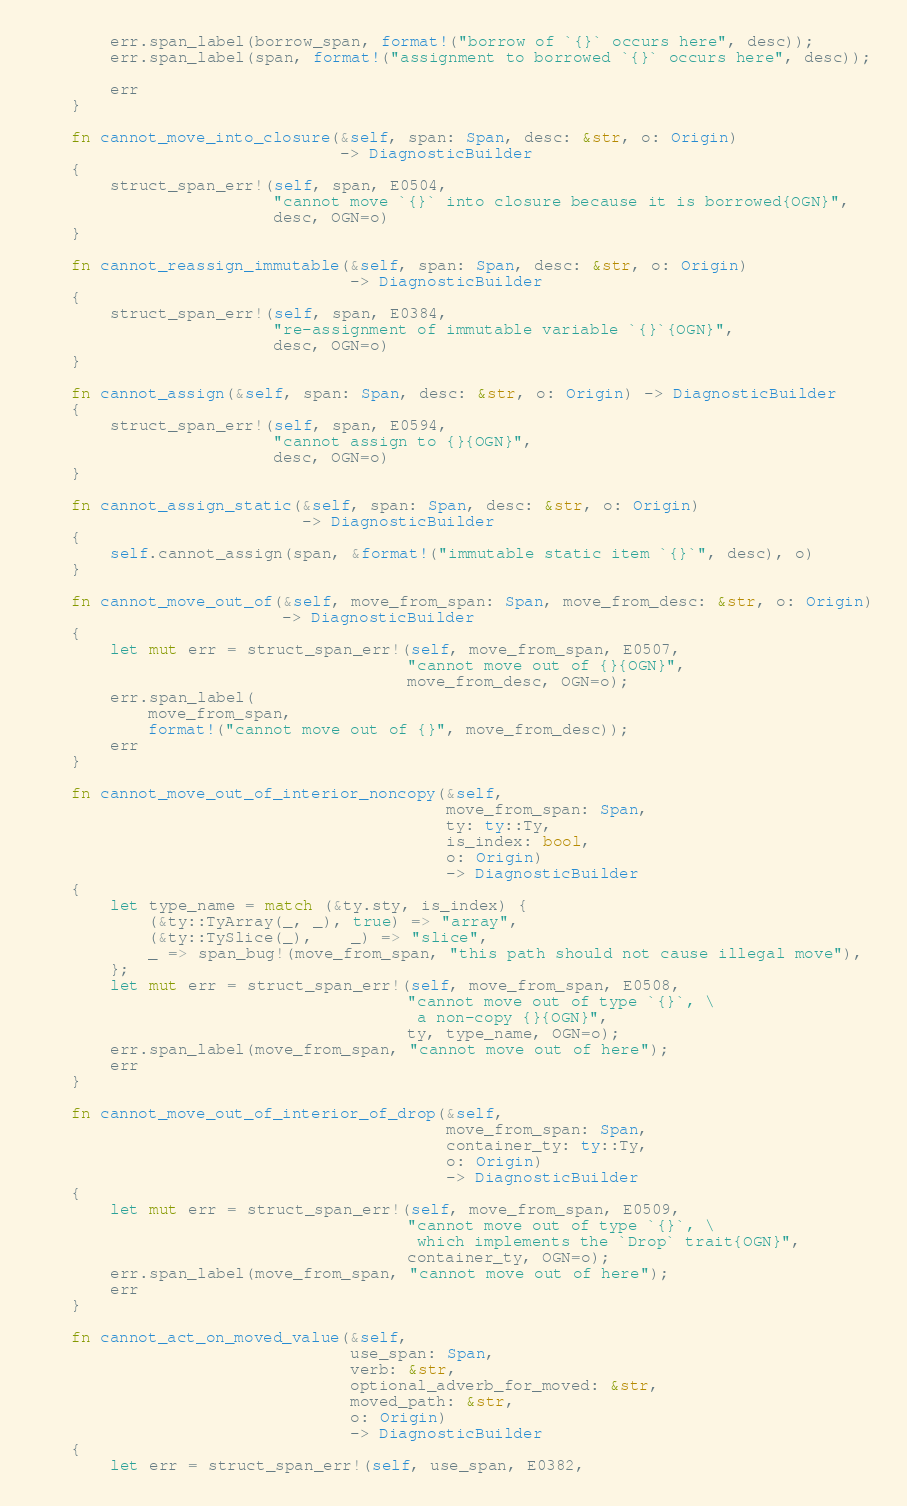<code> <loc_0><loc_0><loc_500><loc_500><_Rust_>        err.span_label(borrow_span, format!("borrow of `{}` occurs here", desc));
        err.span_label(span, format!("assignment to borrowed `{}` occurs here", desc));

        err
    }

    fn cannot_move_into_closure(&self, span: Span, desc: &str, o: Origin)
                                -> DiagnosticBuilder
    {
        struct_span_err!(self, span, E0504,
                         "cannot move `{}` into closure because it is borrowed{OGN}",
                         desc, OGN=o)
    }

    fn cannot_reassign_immutable(&self, span: Span, desc: &str, o: Origin)
                                 -> DiagnosticBuilder
    {
        struct_span_err!(self, span, E0384,
                         "re-assignment of immutable variable `{}`{OGN}",
                         desc, OGN=o)
    }

    fn cannot_assign(&self, span: Span, desc: &str, o: Origin) -> DiagnosticBuilder
    {
        struct_span_err!(self, span, E0594,
                         "cannot assign to {}{OGN}",
                         desc, OGN=o)
    }

    fn cannot_assign_static(&self, span: Span, desc: &str, o: Origin)
                            -> DiagnosticBuilder
    {
        self.cannot_assign(span, &format!("immutable static item `{}`", desc), o)
    }

    fn cannot_move_out_of(&self, move_from_span: Span, move_from_desc: &str, o: Origin)
                          -> DiagnosticBuilder
    {
        let mut err = struct_span_err!(self, move_from_span, E0507,
                                       "cannot move out of {}{OGN}",
                                       move_from_desc, OGN=o);
        err.span_label(
            move_from_span,
            format!("cannot move out of {}", move_from_desc));
        err
    }

    fn cannot_move_out_of_interior_noncopy(&self,
                                           move_from_span: Span,
                                           ty: ty::Ty,
                                           is_index: bool,
                                           o: Origin)
                                           -> DiagnosticBuilder
    {
        let type_name = match (&ty.sty, is_index) {
            (&ty::TyArray(_, _), true) => "array",
            (&ty::TySlice(_),    _) => "slice",
            _ => span_bug!(move_from_span, "this path should not cause illegal move"),
        };
        let mut err = struct_span_err!(self, move_from_span, E0508,
                                       "cannot move out of type `{}`, \
                                        a non-copy {}{OGN}",
                                       ty, type_name, OGN=o);
        err.span_label(move_from_span, "cannot move out of here");
        err
    }

    fn cannot_move_out_of_interior_of_drop(&self,
                                           move_from_span: Span,
                                           container_ty: ty::Ty,
                                           o: Origin)
                                           -> DiagnosticBuilder
    {
        let mut err = struct_span_err!(self, move_from_span, E0509,
                                       "cannot move out of type `{}`, \
                                        which implements the `Drop` trait{OGN}",
                                       container_ty, OGN=o);
        err.span_label(move_from_span, "cannot move out of here");
        err
    }

    fn cannot_act_on_moved_value(&self,
                                 use_span: Span,
                                 verb: &str,
                                 optional_adverb_for_moved: &str,
                                 moved_path: &str,
                                 o: Origin)
                                 -> DiagnosticBuilder
    {
        let err = struct_span_err!(self, use_span, E0382,</code> 